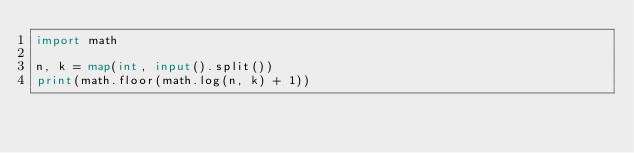Convert code to text. <code><loc_0><loc_0><loc_500><loc_500><_Python_>import math

n, k = map(int, input().split())
print(math.floor(math.log(n, k) + 1))
</code> 